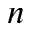Convert formula to latex. <formula><loc_0><loc_0><loc_500><loc_500>n</formula> 